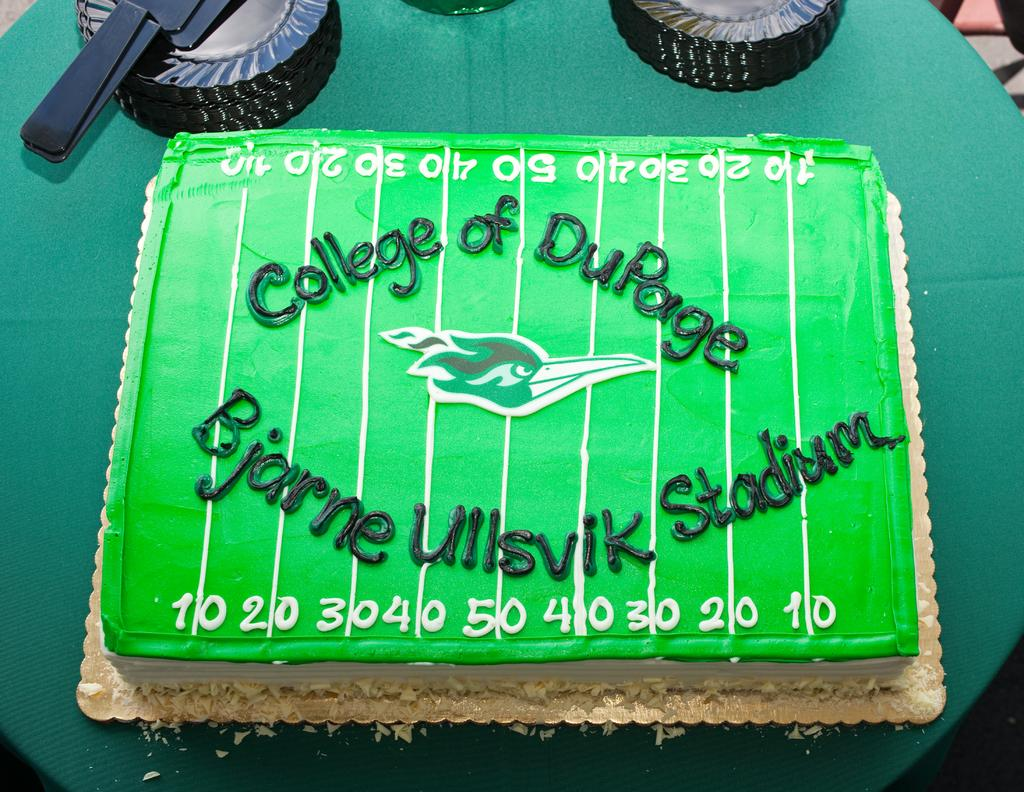What is the main subject of the image? There is a cake in the image. What else can be seen on the table in the image? There are objects on the table in the image. Can you describe the cake in more detail? There is text on the cake. Where is the seat located in the image? There is no seat present in the image. What type of market is depicted in the image? There is no market present in the image. 